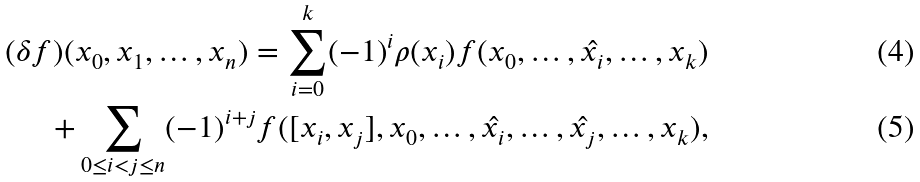Convert formula to latex. <formula><loc_0><loc_0><loc_500><loc_500>( \delta f ) ( x _ { 0 } , x _ { 1 } , \dots , x _ { n } ) = \sum _ { i = 0 } ^ { k } ( - 1 ) ^ { i } \rho ( x _ { i } ) f ( x _ { 0 } , \dots , \hat { x _ { i } } , \dots , x _ { k } ) \\ + \sum _ { 0 \leq i < j \leq n } ( - 1 ) ^ { i + j } f ( [ x _ { i } , x _ { j } ] , x _ { 0 } , \dots , \hat { x _ { i } } , \dots , \hat { x _ { j } } , \dots , x _ { k } ) ,</formula> 